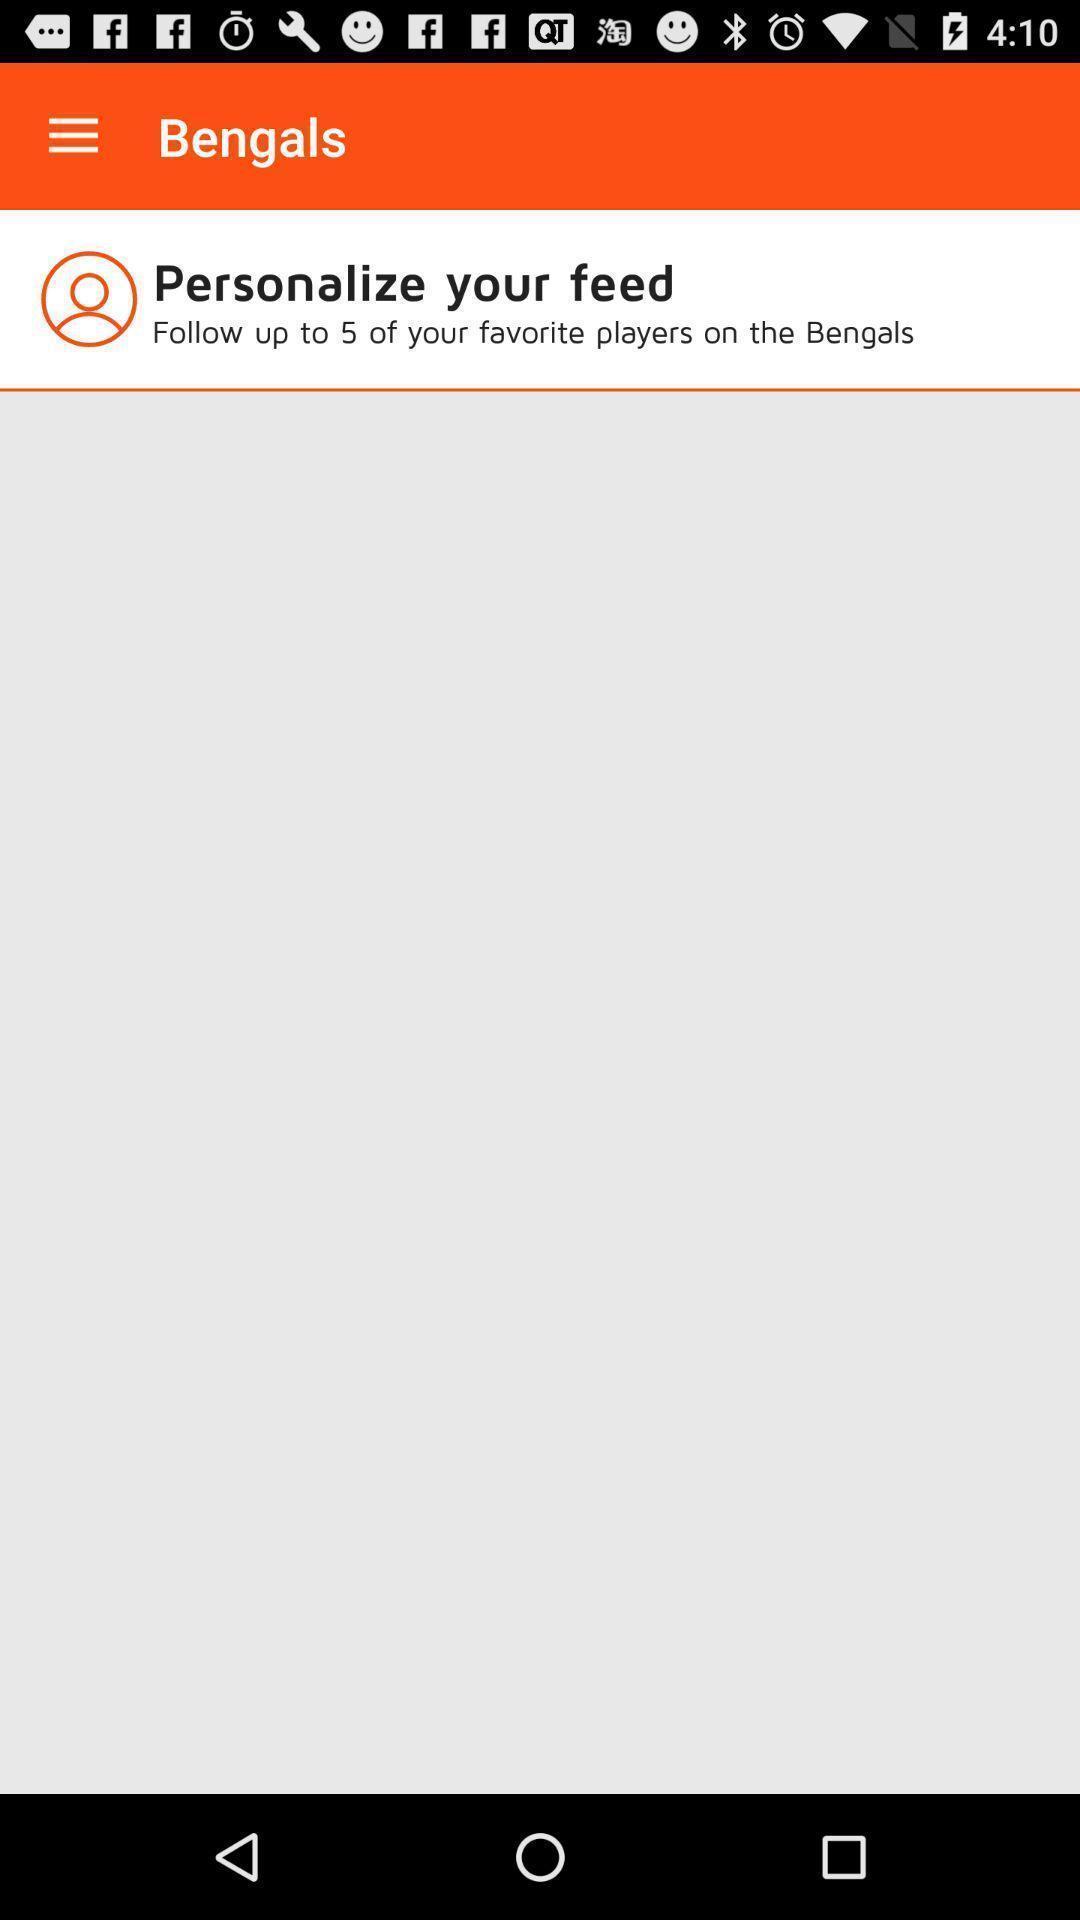What is the overall content of this screenshot? Page displaying personalize your feed. 